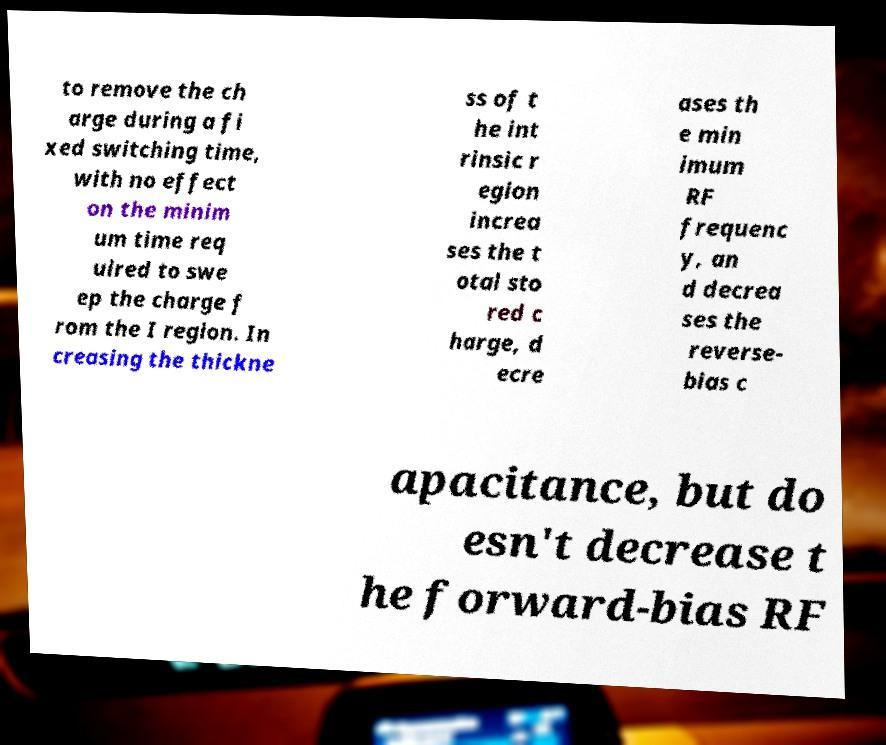Can you read and provide the text displayed in the image?This photo seems to have some interesting text. Can you extract and type it out for me? to remove the ch arge during a fi xed switching time, with no effect on the minim um time req uired to swe ep the charge f rom the I region. In creasing the thickne ss of t he int rinsic r egion increa ses the t otal sto red c harge, d ecre ases th e min imum RF frequenc y, an d decrea ses the reverse- bias c apacitance, but do esn't decrease t he forward-bias RF 